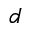Convert formula to latex. <formula><loc_0><loc_0><loc_500><loc_500>d</formula> 